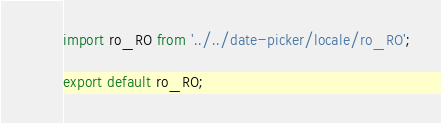<code> <loc_0><loc_0><loc_500><loc_500><_JavaScript_>import ro_RO from '../../date-picker/locale/ro_RO';

export default ro_RO;</code> 